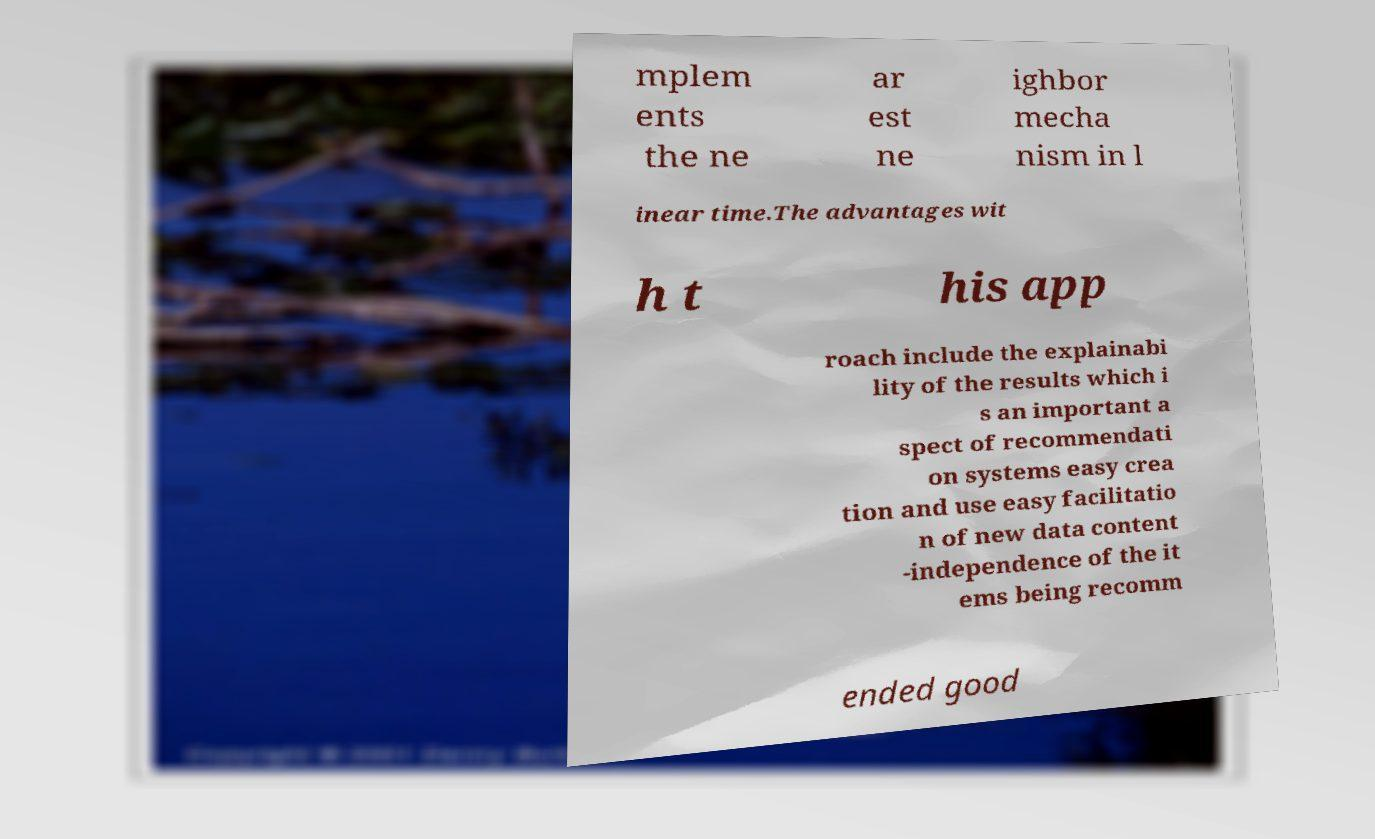What messages or text are displayed in this image? I need them in a readable, typed format. mplem ents the ne ar est ne ighbor mecha nism in l inear time.The advantages wit h t his app roach include the explainabi lity of the results which i s an important a spect of recommendati on systems easy crea tion and use easy facilitatio n of new data content -independence of the it ems being recomm ended good 